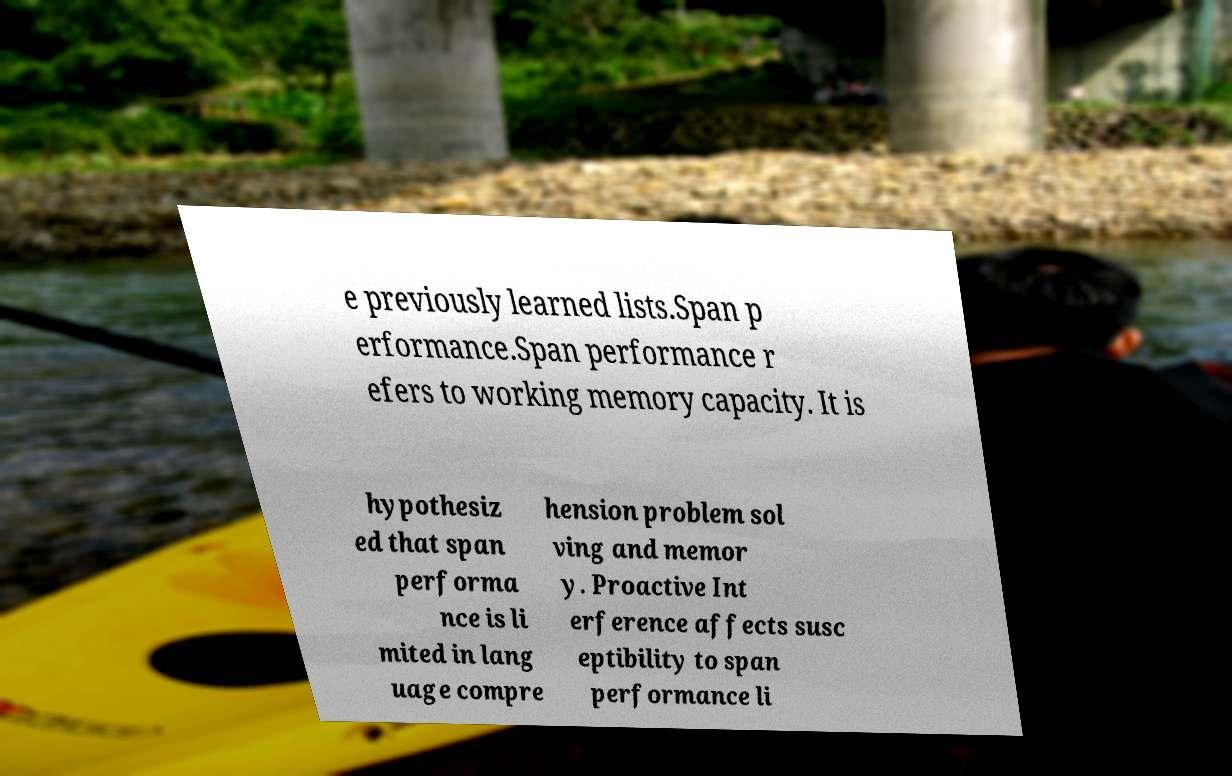What messages or text are displayed in this image? I need them in a readable, typed format. e previously learned lists.Span p erformance.Span performance r efers to working memory capacity. It is hypothesiz ed that span performa nce is li mited in lang uage compre hension problem sol ving and memor y. Proactive Int erference affects susc eptibility to span performance li 